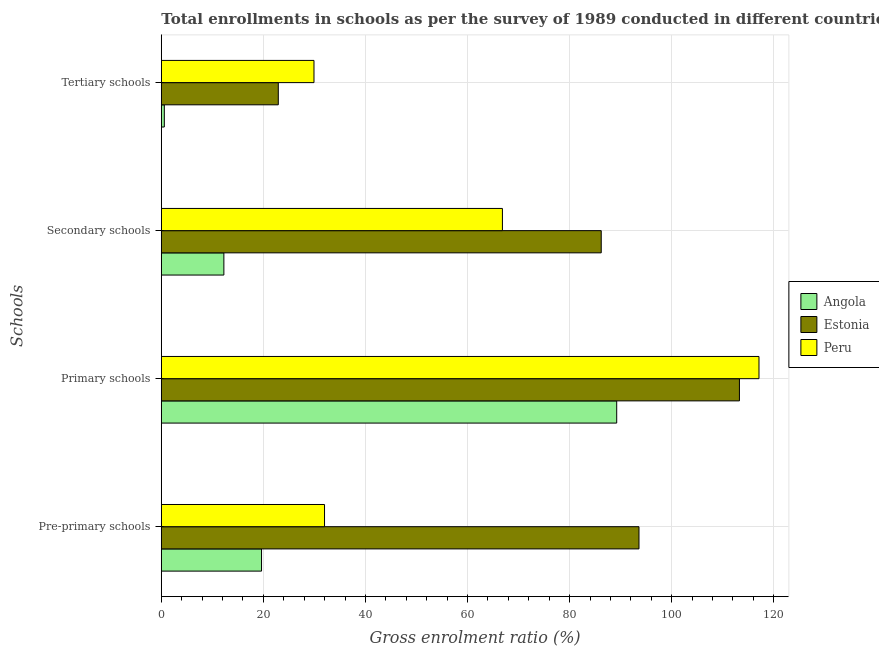How many different coloured bars are there?
Ensure brevity in your answer.  3. How many groups of bars are there?
Give a very brief answer. 4. How many bars are there on the 1st tick from the top?
Your answer should be very brief. 3. How many bars are there on the 1st tick from the bottom?
Your answer should be very brief. 3. What is the label of the 2nd group of bars from the top?
Make the answer very short. Secondary schools. What is the gross enrolment ratio in primary schools in Estonia?
Your response must be concise. 113.27. Across all countries, what is the maximum gross enrolment ratio in primary schools?
Offer a very short reply. 117.1. Across all countries, what is the minimum gross enrolment ratio in tertiary schools?
Give a very brief answer. 0.59. In which country was the gross enrolment ratio in pre-primary schools maximum?
Your response must be concise. Estonia. In which country was the gross enrolment ratio in tertiary schools minimum?
Offer a very short reply. Angola. What is the total gross enrolment ratio in primary schools in the graph?
Offer a very short reply. 319.61. What is the difference between the gross enrolment ratio in pre-primary schools in Peru and that in Estonia?
Make the answer very short. -61.61. What is the difference between the gross enrolment ratio in tertiary schools in Estonia and the gross enrolment ratio in primary schools in Angola?
Your response must be concise. -66.31. What is the average gross enrolment ratio in primary schools per country?
Ensure brevity in your answer.  106.54. What is the difference between the gross enrolment ratio in primary schools and gross enrolment ratio in pre-primary schools in Peru?
Your answer should be compact. 85.13. In how many countries, is the gross enrolment ratio in tertiary schools greater than 104 %?
Your response must be concise. 0. What is the ratio of the gross enrolment ratio in pre-primary schools in Angola to that in Peru?
Offer a terse response. 0.61. Is the gross enrolment ratio in tertiary schools in Estonia less than that in Peru?
Give a very brief answer. Yes. What is the difference between the highest and the second highest gross enrolment ratio in pre-primary schools?
Give a very brief answer. 61.61. What is the difference between the highest and the lowest gross enrolment ratio in tertiary schools?
Offer a terse response. 29.32. In how many countries, is the gross enrolment ratio in pre-primary schools greater than the average gross enrolment ratio in pre-primary schools taken over all countries?
Offer a terse response. 1. Is the sum of the gross enrolment ratio in tertiary schools in Angola and Peru greater than the maximum gross enrolment ratio in primary schools across all countries?
Provide a succinct answer. No. What does the 1st bar from the bottom in Tertiary schools represents?
Offer a very short reply. Angola. Is it the case that in every country, the sum of the gross enrolment ratio in pre-primary schools and gross enrolment ratio in primary schools is greater than the gross enrolment ratio in secondary schools?
Provide a short and direct response. Yes. Are all the bars in the graph horizontal?
Offer a very short reply. Yes. Are the values on the major ticks of X-axis written in scientific E-notation?
Provide a succinct answer. No. Does the graph contain any zero values?
Your answer should be compact. No. Does the graph contain grids?
Ensure brevity in your answer.  Yes. Where does the legend appear in the graph?
Give a very brief answer. Center right. What is the title of the graph?
Offer a terse response. Total enrollments in schools as per the survey of 1989 conducted in different countries. What is the label or title of the Y-axis?
Your response must be concise. Schools. What is the Gross enrolment ratio (%) of Angola in Pre-primary schools?
Your response must be concise. 19.63. What is the Gross enrolment ratio (%) of Estonia in Pre-primary schools?
Keep it short and to the point. 93.59. What is the Gross enrolment ratio (%) of Peru in Pre-primary schools?
Provide a short and direct response. 31.98. What is the Gross enrolment ratio (%) of Angola in Primary schools?
Your response must be concise. 89.23. What is the Gross enrolment ratio (%) in Estonia in Primary schools?
Make the answer very short. 113.27. What is the Gross enrolment ratio (%) in Peru in Primary schools?
Offer a terse response. 117.1. What is the Gross enrolment ratio (%) of Angola in Secondary schools?
Give a very brief answer. 12.26. What is the Gross enrolment ratio (%) in Estonia in Secondary schools?
Ensure brevity in your answer.  86.2. What is the Gross enrolment ratio (%) of Peru in Secondary schools?
Your response must be concise. 66.84. What is the Gross enrolment ratio (%) of Angola in Tertiary schools?
Your answer should be very brief. 0.59. What is the Gross enrolment ratio (%) in Estonia in Tertiary schools?
Your answer should be compact. 22.92. What is the Gross enrolment ratio (%) of Peru in Tertiary schools?
Offer a very short reply. 29.91. Across all Schools, what is the maximum Gross enrolment ratio (%) of Angola?
Offer a very short reply. 89.23. Across all Schools, what is the maximum Gross enrolment ratio (%) in Estonia?
Make the answer very short. 113.27. Across all Schools, what is the maximum Gross enrolment ratio (%) of Peru?
Make the answer very short. 117.1. Across all Schools, what is the minimum Gross enrolment ratio (%) of Angola?
Offer a very short reply. 0.59. Across all Schools, what is the minimum Gross enrolment ratio (%) in Estonia?
Keep it short and to the point. 22.92. Across all Schools, what is the minimum Gross enrolment ratio (%) of Peru?
Make the answer very short. 29.91. What is the total Gross enrolment ratio (%) in Angola in the graph?
Offer a very short reply. 121.71. What is the total Gross enrolment ratio (%) of Estonia in the graph?
Provide a short and direct response. 315.98. What is the total Gross enrolment ratio (%) in Peru in the graph?
Your response must be concise. 245.83. What is the difference between the Gross enrolment ratio (%) in Angola in Pre-primary schools and that in Primary schools?
Your response must be concise. -69.59. What is the difference between the Gross enrolment ratio (%) in Estonia in Pre-primary schools and that in Primary schools?
Provide a short and direct response. -19.68. What is the difference between the Gross enrolment ratio (%) of Peru in Pre-primary schools and that in Primary schools?
Your answer should be compact. -85.13. What is the difference between the Gross enrolment ratio (%) in Angola in Pre-primary schools and that in Secondary schools?
Offer a very short reply. 7.38. What is the difference between the Gross enrolment ratio (%) in Estonia in Pre-primary schools and that in Secondary schools?
Your answer should be very brief. 7.39. What is the difference between the Gross enrolment ratio (%) of Peru in Pre-primary schools and that in Secondary schools?
Keep it short and to the point. -34.86. What is the difference between the Gross enrolment ratio (%) in Angola in Pre-primary schools and that in Tertiary schools?
Make the answer very short. 19.04. What is the difference between the Gross enrolment ratio (%) of Estonia in Pre-primary schools and that in Tertiary schools?
Keep it short and to the point. 70.67. What is the difference between the Gross enrolment ratio (%) in Peru in Pre-primary schools and that in Tertiary schools?
Ensure brevity in your answer.  2.07. What is the difference between the Gross enrolment ratio (%) of Angola in Primary schools and that in Secondary schools?
Give a very brief answer. 76.97. What is the difference between the Gross enrolment ratio (%) in Estonia in Primary schools and that in Secondary schools?
Give a very brief answer. 27.08. What is the difference between the Gross enrolment ratio (%) of Peru in Primary schools and that in Secondary schools?
Provide a succinct answer. 50.27. What is the difference between the Gross enrolment ratio (%) in Angola in Primary schools and that in Tertiary schools?
Keep it short and to the point. 88.64. What is the difference between the Gross enrolment ratio (%) in Estonia in Primary schools and that in Tertiary schools?
Provide a succinct answer. 90.35. What is the difference between the Gross enrolment ratio (%) in Peru in Primary schools and that in Tertiary schools?
Your answer should be compact. 87.19. What is the difference between the Gross enrolment ratio (%) of Angola in Secondary schools and that in Tertiary schools?
Provide a short and direct response. 11.67. What is the difference between the Gross enrolment ratio (%) of Estonia in Secondary schools and that in Tertiary schools?
Your response must be concise. 63.27. What is the difference between the Gross enrolment ratio (%) of Peru in Secondary schools and that in Tertiary schools?
Your answer should be compact. 36.92. What is the difference between the Gross enrolment ratio (%) of Angola in Pre-primary schools and the Gross enrolment ratio (%) of Estonia in Primary schools?
Keep it short and to the point. -93.64. What is the difference between the Gross enrolment ratio (%) in Angola in Pre-primary schools and the Gross enrolment ratio (%) in Peru in Primary schools?
Provide a short and direct response. -97.47. What is the difference between the Gross enrolment ratio (%) of Estonia in Pre-primary schools and the Gross enrolment ratio (%) of Peru in Primary schools?
Offer a very short reply. -23.51. What is the difference between the Gross enrolment ratio (%) in Angola in Pre-primary schools and the Gross enrolment ratio (%) in Estonia in Secondary schools?
Your answer should be compact. -66.56. What is the difference between the Gross enrolment ratio (%) of Angola in Pre-primary schools and the Gross enrolment ratio (%) of Peru in Secondary schools?
Offer a terse response. -47.2. What is the difference between the Gross enrolment ratio (%) in Estonia in Pre-primary schools and the Gross enrolment ratio (%) in Peru in Secondary schools?
Provide a short and direct response. 26.76. What is the difference between the Gross enrolment ratio (%) in Angola in Pre-primary schools and the Gross enrolment ratio (%) in Estonia in Tertiary schools?
Provide a short and direct response. -3.29. What is the difference between the Gross enrolment ratio (%) in Angola in Pre-primary schools and the Gross enrolment ratio (%) in Peru in Tertiary schools?
Your response must be concise. -10.28. What is the difference between the Gross enrolment ratio (%) in Estonia in Pre-primary schools and the Gross enrolment ratio (%) in Peru in Tertiary schools?
Give a very brief answer. 63.68. What is the difference between the Gross enrolment ratio (%) in Angola in Primary schools and the Gross enrolment ratio (%) in Estonia in Secondary schools?
Make the answer very short. 3.03. What is the difference between the Gross enrolment ratio (%) in Angola in Primary schools and the Gross enrolment ratio (%) in Peru in Secondary schools?
Keep it short and to the point. 22.39. What is the difference between the Gross enrolment ratio (%) of Estonia in Primary schools and the Gross enrolment ratio (%) of Peru in Secondary schools?
Provide a succinct answer. 46.44. What is the difference between the Gross enrolment ratio (%) in Angola in Primary schools and the Gross enrolment ratio (%) in Estonia in Tertiary schools?
Offer a very short reply. 66.31. What is the difference between the Gross enrolment ratio (%) of Angola in Primary schools and the Gross enrolment ratio (%) of Peru in Tertiary schools?
Provide a succinct answer. 59.31. What is the difference between the Gross enrolment ratio (%) of Estonia in Primary schools and the Gross enrolment ratio (%) of Peru in Tertiary schools?
Give a very brief answer. 83.36. What is the difference between the Gross enrolment ratio (%) of Angola in Secondary schools and the Gross enrolment ratio (%) of Estonia in Tertiary schools?
Offer a terse response. -10.67. What is the difference between the Gross enrolment ratio (%) of Angola in Secondary schools and the Gross enrolment ratio (%) of Peru in Tertiary schools?
Offer a terse response. -17.66. What is the difference between the Gross enrolment ratio (%) of Estonia in Secondary schools and the Gross enrolment ratio (%) of Peru in Tertiary schools?
Offer a very short reply. 56.28. What is the average Gross enrolment ratio (%) of Angola per Schools?
Provide a succinct answer. 30.43. What is the average Gross enrolment ratio (%) in Estonia per Schools?
Your answer should be compact. 79. What is the average Gross enrolment ratio (%) in Peru per Schools?
Your response must be concise. 61.46. What is the difference between the Gross enrolment ratio (%) in Angola and Gross enrolment ratio (%) in Estonia in Pre-primary schools?
Provide a short and direct response. -73.96. What is the difference between the Gross enrolment ratio (%) of Angola and Gross enrolment ratio (%) of Peru in Pre-primary schools?
Make the answer very short. -12.34. What is the difference between the Gross enrolment ratio (%) of Estonia and Gross enrolment ratio (%) of Peru in Pre-primary schools?
Your answer should be very brief. 61.61. What is the difference between the Gross enrolment ratio (%) in Angola and Gross enrolment ratio (%) in Estonia in Primary schools?
Provide a short and direct response. -24.05. What is the difference between the Gross enrolment ratio (%) of Angola and Gross enrolment ratio (%) of Peru in Primary schools?
Keep it short and to the point. -27.88. What is the difference between the Gross enrolment ratio (%) in Estonia and Gross enrolment ratio (%) in Peru in Primary schools?
Your answer should be compact. -3.83. What is the difference between the Gross enrolment ratio (%) of Angola and Gross enrolment ratio (%) of Estonia in Secondary schools?
Your answer should be compact. -73.94. What is the difference between the Gross enrolment ratio (%) in Angola and Gross enrolment ratio (%) in Peru in Secondary schools?
Ensure brevity in your answer.  -54.58. What is the difference between the Gross enrolment ratio (%) in Estonia and Gross enrolment ratio (%) in Peru in Secondary schools?
Provide a succinct answer. 19.36. What is the difference between the Gross enrolment ratio (%) in Angola and Gross enrolment ratio (%) in Estonia in Tertiary schools?
Offer a terse response. -22.33. What is the difference between the Gross enrolment ratio (%) in Angola and Gross enrolment ratio (%) in Peru in Tertiary schools?
Offer a terse response. -29.32. What is the difference between the Gross enrolment ratio (%) of Estonia and Gross enrolment ratio (%) of Peru in Tertiary schools?
Your response must be concise. -6.99. What is the ratio of the Gross enrolment ratio (%) of Angola in Pre-primary schools to that in Primary schools?
Offer a very short reply. 0.22. What is the ratio of the Gross enrolment ratio (%) of Estonia in Pre-primary schools to that in Primary schools?
Your answer should be compact. 0.83. What is the ratio of the Gross enrolment ratio (%) in Peru in Pre-primary schools to that in Primary schools?
Your answer should be very brief. 0.27. What is the ratio of the Gross enrolment ratio (%) in Angola in Pre-primary schools to that in Secondary schools?
Offer a terse response. 1.6. What is the ratio of the Gross enrolment ratio (%) in Estonia in Pre-primary schools to that in Secondary schools?
Your answer should be compact. 1.09. What is the ratio of the Gross enrolment ratio (%) of Peru in Pre-primary schools to that in Secondary schools?
Provide a succinct answer. 0.48. What is the ratio of the Gross enrolment ratio (%) in Angola in Pre-primary schools to that in Tertiary schools?
Offer a very short reply. 33.23. What is the ratio of the Gross enrolment ratio (%) of Estonia in Pre-primary schools to that in Tertiary schools?
Ensure brevity in your answer.  4.08. What is the ratio of the Gross enrolment ratio (%) in Peru in Pre-primary schools to that in Tertiary schools?
Keep it short and to the point. 1.07. What is the ratio of the Gross enrolment ratio (%) of Angola in Primary schools to that in Secondary schools?
Make the answer very short. 7.28. What is the ratio of the Gross enrolment ratio (%) of Estonia in Primary schools to that in Secondary schools?
Provide a short and direct response. 1.31. What is the ratio of the Gross enrolment ratio (%) of Peru in Primary schools to that in Secondary schools?
Offer a terse response. 1.75. What is the ratio of the Gross enrolment ratio (%) in Angola in Primary schools to that in Tertiary schools?
Offer a terse response. 151.02. What is the ratio of the Gross enrolment ratio (%) of Estonia in Primary schools to that in Tertiary schools?
Make the answer very short. 4.94. What is the ratio of the Gross enrolment ratio (%) in Peru in Primary schools to that in Tertiary schools?
Provide a short and direct response. 3.91. What is the ratio of the Gross enrolment ratio (%) in Angola in Secondary schools to that in Tertiary schools?
Provide a short and direct response. 20.74. What is the ratio of the Gross enrolment ratio (%) of Estonia in Secondary schools to that in Tertiary schools?
Your response must be concise. 3.76. What is the ratio of the Gross enrolment ratio (%) of Peru in Secondary schools to that in Tertiary schools?
Your answer should be very brief. 2.23. What is the difference between the highest and the second highest Gross enrolment ratio (%) in Angola?
Your response must be concise. 69.59. What is the difference between the highest and the second highest Gross enrolment ratio (%) of Estonia?
Ensure brevity in your answer.  19.68. What is the difference between the highest and the second highest Gross enrolment ratio (%) in Peru?
Your response must be concise. 50.27. What is the difference between the highest and the lowest Gross enrolment ratio (%) in Angola?
Provide a short and direct response. 88.64. What is the difference between the highest and the lowest Gross enrolment ratio (%) of Estonia?
Ensure brevity in your answer.  90.35. What is the difference between the highest and the lowest Gross enrolment ratio (%) of Peru?
Your answer should be very brief. 87.19. 